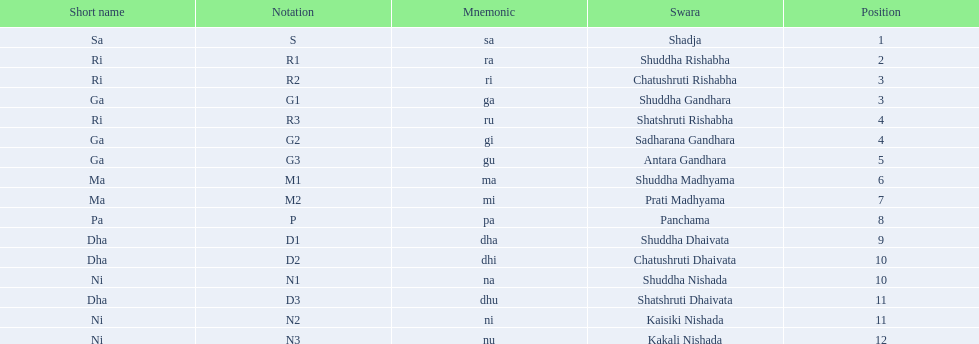How many swaras do not have dhaivata in their name? 13. 